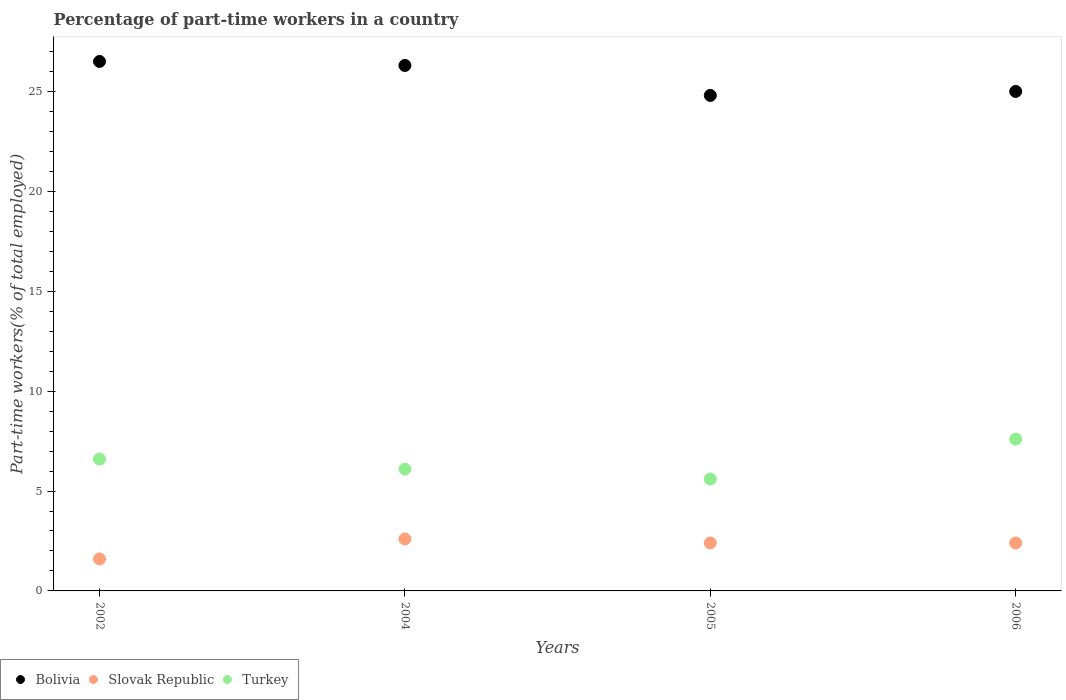Is the number of dotlines equal to the number of legend labels?
Your answer should be compact. Yes. What is the percentage of part-time workers in Slovak Republic in 2004?
Keep it short and to the point. 2.6. Across all years, what is the maximum percentage of part-time workers in Turkey?
Give a very brief answer. 7.6. Across all years, what is the minimum percentage of part-time workers in Bolivia?
Keep it short and to the point. 24.8. In which year was the percentage of part-time workers in Slovak Republic minimum?
Give a very brief answer. 2002. What is the total percentage of part-time workers in Slovak Republic in the graph?
Your answer should be compact. 9. What is the difference between the percentage of part-time workers in Slovak Republic in 2005 and that in 2006?
Provide a succinct answer. 0. What is the difference between the percentage of part-time workers in Turkey in 2006 and the percentage of part-time workers in Bolivia in 2002?
Give a very brief answer. -18.9. What is the average percentage of part-time workers in Bolivia per year?
Your response must be concise. 25.65. In the year 2002, what is the difference between the percentage of part-time workers in Turkey and percentage of part-time workers in Slovak Republic?
Make the answer very short. 5. What is the ratio of the percentage of part-time workers in Bolivia in 2004 to that in 2006?
Give a very brief answer. 1.05. Is the percentage of part-time workers in Bolivia in 2002 less than that in 2005?
Your answer should be compact. No. What is the difference between the highest and the second highest percentage of part-time workers in Turkey?
Ensure brevity in your answer.  1. What is the difference between the highest and the lowest percentage of part-time workers in Turkey?
Provide a short and direct response. 2. Is the sum of the percentage of part-time workers in Slovak Republic in 2004 and 2006 greater than the maximum percentage of part-time workers in Bolivia across all years?
Give a very brief answer. No. Is it the case that in every year, the sum of the percentage of part-time workers in Slovak Republic and percentage of part-time workers in Turkey  is greater than the percentage of part-time workers in Bolivia?
Your answer should be very brief. No. Does the percentage of part-time workers in Slovak Republic monotonically increase over the years?
Make the answer very short. No. Is the percentage of part-time workers in Bolivia strictly greater than the percentage of part-time workers in Turkey over the years?
Offer a very short reply. Yes. Is the percentage of part-time workers in Slovak Republic strictly less than the percentage of part-time workers in Bolivia over the years?
Ensure brevity in your answer.  Yes. How many dotlines are there?
Offer a terse response. 3. What is the difference between two consecutive major ticks on the Y-axis?
Your response must be concise. 5. Does the graph contain any zero values?
Offer a terse response. No. How many legend labels are there?
Provide a succinct answer. 3. What is the title of the graph?
Ensure brevity in your answer.  Percentage of part-time workers in a country. What is the label or title of the X-axis?
Your answer should be very brief. Years. What is the label or title of the Y-axis?
Keep it short and to the point. Part-time workers(% of total employed). What is the Part-time workers(% of total employed) of Slovak Republic in 2002?
Your answer should be very brief. 1.6. What is the Part-time workers(% of total employed) in Turkey in 2002?
Your answer should be compact. 6.6. What is the Part-time workers(% of total employed) of Bolivia in 2004?
Provide a succinct answer. 26.3. What is the Part-time workers(% of total employed) in Slovak Republic in 2004?
Offer a very short reply. 2.6. What is the Part-time workers(% of total employed) of Turkey in 2004?
Offer a very short reply. 6.1. What is the Part-time workers(% of total employed) of Bolivia in 2005?
Offer a very short reply. 24.8. What is the Part-time workers(% of total employed) of Slovak Republic in 2005?
Your response must be concise. 2.4. What is the Part-time workers(% of total employed) in Turkey in 2005?
Your answer should be very brief. 5.6. What is the Part-time workers(% of total employed) in Bolivia in 2006?
Offer a terse response. 25. What is the Part-time workers(% of total employed) of Slovak Republic in 2006?
Make the answer very short. 2.4. What is the Part-time workers(% of total employed) in Turkey in 2006?
Your answer should be compact. 7.6. Across all years, what is the maximum Part-time workers(% of total employed) of Slovak Republic?
Keep it short and to the point. 2.6. Across all years, what is the maximum Part-time workers(% of total employed) in Turkey?
Your answer should be compact. 7.6. Across all years, what is the minimum Part-time workers(% of total employed) of Bolivia?
Offer a terse response. 24.8. Across all years, what is the minimum Part-time workers(% of total employed) of Slovak Republic?
Give a very brief answer. 1.6. Across all years, what is the minimum Part-time workers(% of total employed) in Turkey?
Your answer should be very brief. 5.6. What is the total Part-time workers(% of total employed) in Bolivia in the graph?
Ensure brevity in your answer.  102.6. What is the total Part-time workers(% of total employed) in Turkey in the graph?
Make the answer very short. 25.9. What is the difference between the Part-time workers(% of total employed) in Turkey in 2002 and that in 2005?
Your answer should be very brief. 1. What is the difference between the Part-time workers(% of total employed) in Turkey in 2002 and that in 2006?
Your answer should be compact. -1. What is the difference between the Part-time workers(% of total employed) of Bolivia in 2004 and that in 2006?
Give a very brief answer. 1.3. What is the difference between the Part-time workers(% of total employed) of Bolivia in 2005 and that in 2006?
Your answer should be compact. -0.2. What is the difference between the Part-time workers(% of total employed) in Slovak Republic in 2005 and that in 2006?
Offer a very short reply. 0. What is the difference between the Part-time workers(% of total employed) in Bolivia in 2002 and the Part-time workers(% of total employed) in Slovak Republic in 2004?
Your answer should be very brief. 23.9. What is the difference between the Part-time workers(% of total employed) in Bolivia in 2002 and the Part-time workers(% of total employed) in Turkey in 2004?
Make the answer very short. 20.4. What is the difference between the Part-time workers(% of total employed) of Bolivia in 2002 and the Part-time workers(% of total employed) of Slovak Republic in 2005?
Offer a very short reply. 24.1. What is the difference between the Part-time workers(% of total employed) in Bolivia in 2002 and the Part-time workers(% of total employed) in Turkey in 2005?
Your response must be concise. 20.9. What is the difference between the Part-time workers(% of total employed) of Bolivia in 2002 and the Part-time workers(% of total employed) of Slovak Republic in 2006?
Keep it short and to the point. 24.1. What is the difference between the Part-time workers(% of total employed) in Bolivia in 2002 and the Part-time workers(% of total employed) in Turkey in 2006?
Provide a short and direct response. 18.9. What is the difference between the Part-time workers(% of total employed) of Slovak Republic in 2002 and the Part-time workers(% of total employed) of Turkey in 2006?
Provide a succinct answer. -6. What is the difference between the Part-time workers(% of total employed) of Bolivia in 2004 and the Part-time workers(% of total employed) of Slovak Republic in 2005?
Ensure brevity in your answer.  23.9. What is the difference between the Part-time workers(% of total employed) in Bolivia in 2004 and the Part-time workers(% of total employed) in Turkey in 2005?
Your answer should be compact. 20.7. What is the difference between the Part-time workers(% of total employed) in Slovak Republic in 2004 and the Part-time workers(% of total employed) in Turkey in 2005?
Provide a succinct answer. -3. What is the difference between the Part-time workers(% of total employed) of Bolivia in 2004 and the Part-time workers(% of total employed) of Slovak Republic in 2006?
Give a very brief answer. 23.9. What is the difference between the Part-time workers(% of total employed) in Slovak Republic in 2004 and the Part-time workers(% of total employed) in Turkey in 2006?
Your answer should be compact. -5. What is the difference between the Part-time workers(% of total employed) of Bolivia in 2005 and the Part-time workers(% of total employed) of Slovak Republic in 2006?
Offer a terse response. 22.4. What is the difference between the Part-time workers(% of total employed) in Bolivia in 2005 and the Part-time workers(% of total employed) in Turkey in 2006?
Give a very brief answer. 17.2. What is the difference between the Part-time workers(% of total employed) in Slovak Republic in 2005 and the Part-time workers(% of total employed) in Turkey in 2006?
Give a very brief answer. -5.2. What is the average Part-time workers(% of total employed) of Bolivia per year?
Ensure brevity in your answer.  25.65. What is the average Part-time workers(% of total employed) in Slovak Republic per year?
Offer a terse response. 2.25. What is the average Part-time workers(% of total employed) of Turkey per year?
Keep it short and to the point. 6.47. In the year 2002, what is the difference between the Part-time workers(% of total employed) of Bolivia and Part-time workers(% of total employed) of Slovak Republic?
Your answer should be very brief. 24.9. In the year 2004, what is the difference between the Part-time workers(% of total employed) in Bolivia and Part-time workers(% of total employed) in Slovak Republic?
Ensure brevity in your answer.  23.7. In the year 2004, what is the difference between the Part-time workers(% of total employed) of Bolivia and Part-time workers(% of total employed) of Turkey?
Give a very brief answer. 20.2. In the year 2004, what is the difference between the Part-time workers(% of total employed) of Slovak Republic and Part-time workers(% of total employed) of Turkey?
Your response must be concise. -3.5. In the year 2005, what is the difference between the Part-time workers(% of total employed) of Bolivia and Part-time workers(% of total employed) of Slovak Republic?
Offer a terse response. 22.4. In the year 2005, what is the difference between the Part-time workers(% of total employed) of Slovak Republic and Part-time workers(% of total employed) of Turkey?
Offer a very short reply. -3.2. In the year 2006, what is the difference between the Part-time workers(% of total employed) in Bolivia and Part-time workers(% of total employed) in Slovak Republic?
Give a very brief answer. 22.6. In the year 2006, what is the difference between the Part-time workers(% of total employed) of Bolivia and Part-time workers(% of total employed) of Turkey?
Provide a short and direct response. 17.4. In the year 2006, what is the difference between the Part-time workers(% of total employed) of Slovak Republic and Part-time workers(% of total employed) of Turkey?
Provide a succinct answer. -5.2. What is the ratio of the Part-time workers(% of total employed) in Bolivia in 2002 to that in 2004?
Give a very brief answer. 1.01. What is the ratio of the Part-time workers(% of total employed) of Slovak Republic in 2002 to that in 2004?
Your response must be concise. 0.62. What is the ratio of the Part-time workers(% of total employed) of Turkey in 2002 to that in 2004?
Your answer should be very brief. 1.08. What is the ratio of the Part-time workers(% of total employed) of Bolivia in 2002 to that in 2005?
Your response must be concise. 1.07. What is the ratio of the Part-time workers(% of total employed) of Slovak Republic in 2002 to that in 2005?
Provide a succinct answer. 0.67. What is the ratio of the Part-time workers(% of total employed) of Turkey in 2002 to that in 2005?
Your response must be concise. 1.18. What is the ratio of the Part-time workers(% of total employed) in Bolivia in 2002 to that in 2006?
Your response must be concise. 1.06. What is the ratio of the Part-time workers(% of total employed) in Slovak Republic in 2002 to that in 2006?
Make the answer very short. 0.67. What is the ratio of the Part-time workers(% of total employed) in Turkey in 2002 to that in 2006?
Ensure brevity in your answer.  0.87. What is the ratio of the Part-time workers(% of total employed) in Bolivia in 2004 to that in 2005?
Your answer should be compact. 1.06. What is the ratio of the Part-time workers(% of total employed) of Turkey in 2004 to that in 2005?
Give a very brief answer. 1.09. What is the ratio of the Part-time workers(% of total employed) in Bolivia in 2004 to that in 2006?
Make the answer very short. 1.05. What is the ratio of the Part-time workers(% of total employed) in Slovak Republic in 2004 to that in 2006?
Ensure brevity in your answer.  1.08. What is the ratio of the Part-time workers(% of total employed) in Turkey in 2004 to that in 2006?
Offer a terse response. 0.8. What is the ratio of the Part-time workers(% of total employed) of Bolivia in 2005 to that in 2006?
Offer a very short reply. 0.99. What is the ratio of the Part-time workers(% of total employed) in Slovak Republic in 2005 to that in 2006?
Offer a very short reply. 1. What is the ratio of the Part-time workers(% of total employed) in Turkey in 2005 to that in 2006?
Make the answer very short. 0.74. What is the difference between the highest and the second highest Part-time workers(% of total employed) of Bolivia?
Your answer should be very brief. 0.2. What is the difference between the highest and the second highest Part-time workers(% of total employed) in Turkey?
Keep it short and to the point. 1. 